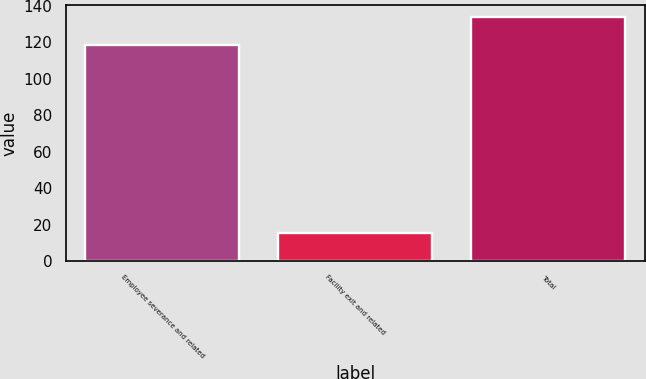Convert chart to OTSL. <chart><loc_0><loc_0><loc_500><loc_500><bar_chart><fcel>Employee severance and related<fcel>Facility exit and related<fcel>Total<nl><fcel>118.5<fcel>15.5<fcel>134<nl></chart> 